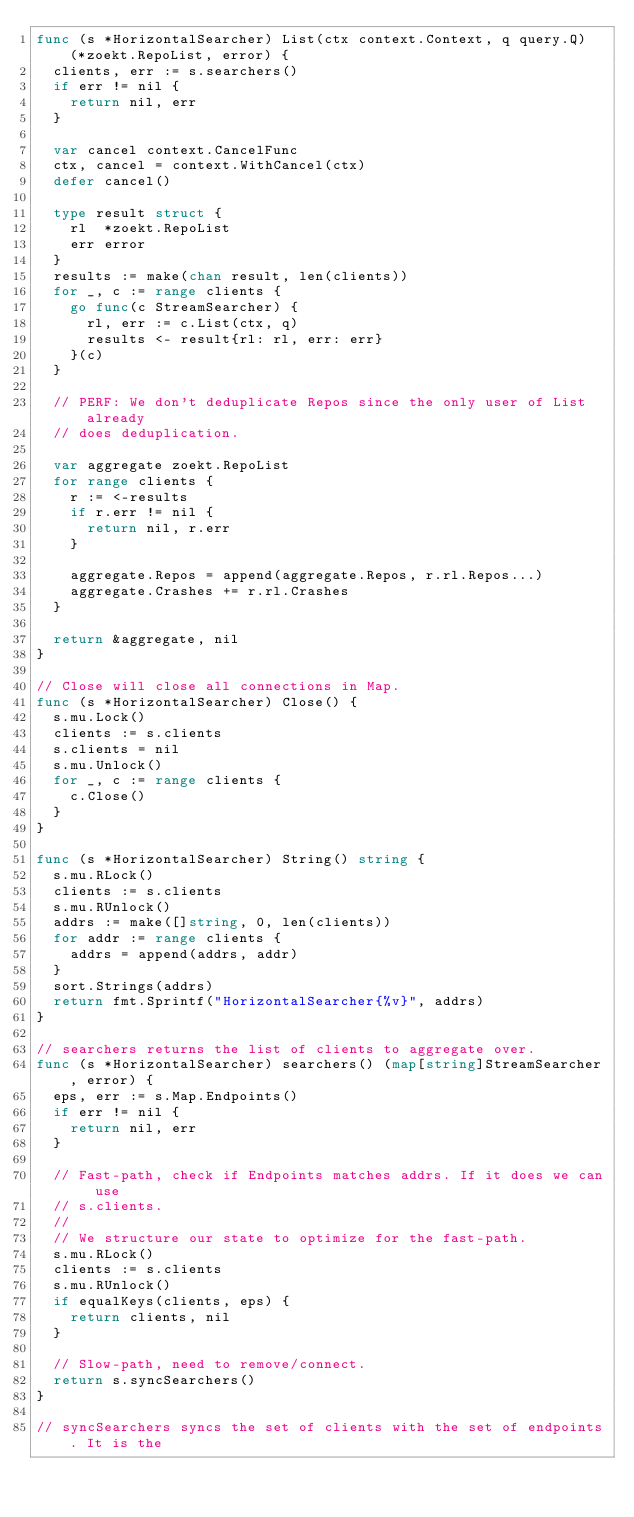Convert code to text. <code><loc_0><loc_0><loc_500><loc_500><_Go_>func (s *HorizontalSearcher) List(ctx context.Context, q query.Q) (*zoekt.RepoList, error) {
	clients, err := s.searchers()
	if err != nil {
		return nil, err
	}

	var cancel context.CancelFunc
	ctx, cancel = context.WithCancel(ctx)
	defer cancel()

	type result struct {
		rl  *zoekt.RepoList
		err error
	}
	results := make(chan result, len(clients))
	for _, c := range clients {
		go func(c StreamSearcher) {
			rl, err := c.List(ctx, q)
			results <- result{rl: rl, err: err}
		}(c)
	}

	// PERF: We don't deduplicate Repos since the only user of List already
	// does deduplication.

	var aggregate zoekt.RepoList
	for range clients {
		r := <-results
		if r.err != nil {
			return nil, r.err
		}

		aggregate.Repos = append(aggregate.Repos, r.rl.Repos...)
		aggregate.Crashes += r.rl.Crashes
	}

	return &aggregate, nil
}

// Close will close all connections in Map.
func (s *HorizontalSearcher) Close() {
	s.mu.Lock()
	clients := s.clients
	s.clients = nil
	s.mu.Unlock()
	for _, c := range clients {
		c.Close()
	}
}

func (s *HorizontalSearcher) String() string {
	s.mu.RLock()
	clients := s.clients
	s.mu.RUnlock()
	addrs := make([]string, 0, len(clients))
	for addr := range clients {
		addrs = append(addrs, addr)
	}
	sort.Strings(addrs)
	return fmt.Sprintf("HorizontalSearcher{%v}", addrs)
}

// searchers returns the list of clients to aggregate over.
func (s *HorizontalSearcher) searchers() (map[string]StreamSearcher, error) {
	eps, err := s.Map.Endpoints()
	if err != nil {
		return nil, err
	}

	// Fast-path, check if Endpoints matches addrs. If it does we can use
	// s.clients.
	//
	// We structure our state to optimize for the fast-path.
	s.mu.RLock()
	clients := s.clients
	s.mu.RUnlock()
	if equalKeys(clients, eps) {
		return clients, nil
	}

	// Slow-path, need to remove/connect.
	return s.syncSearchers()
}

// syncSearchers syncs the set of clients with the set of endpoints. It is the</code> 